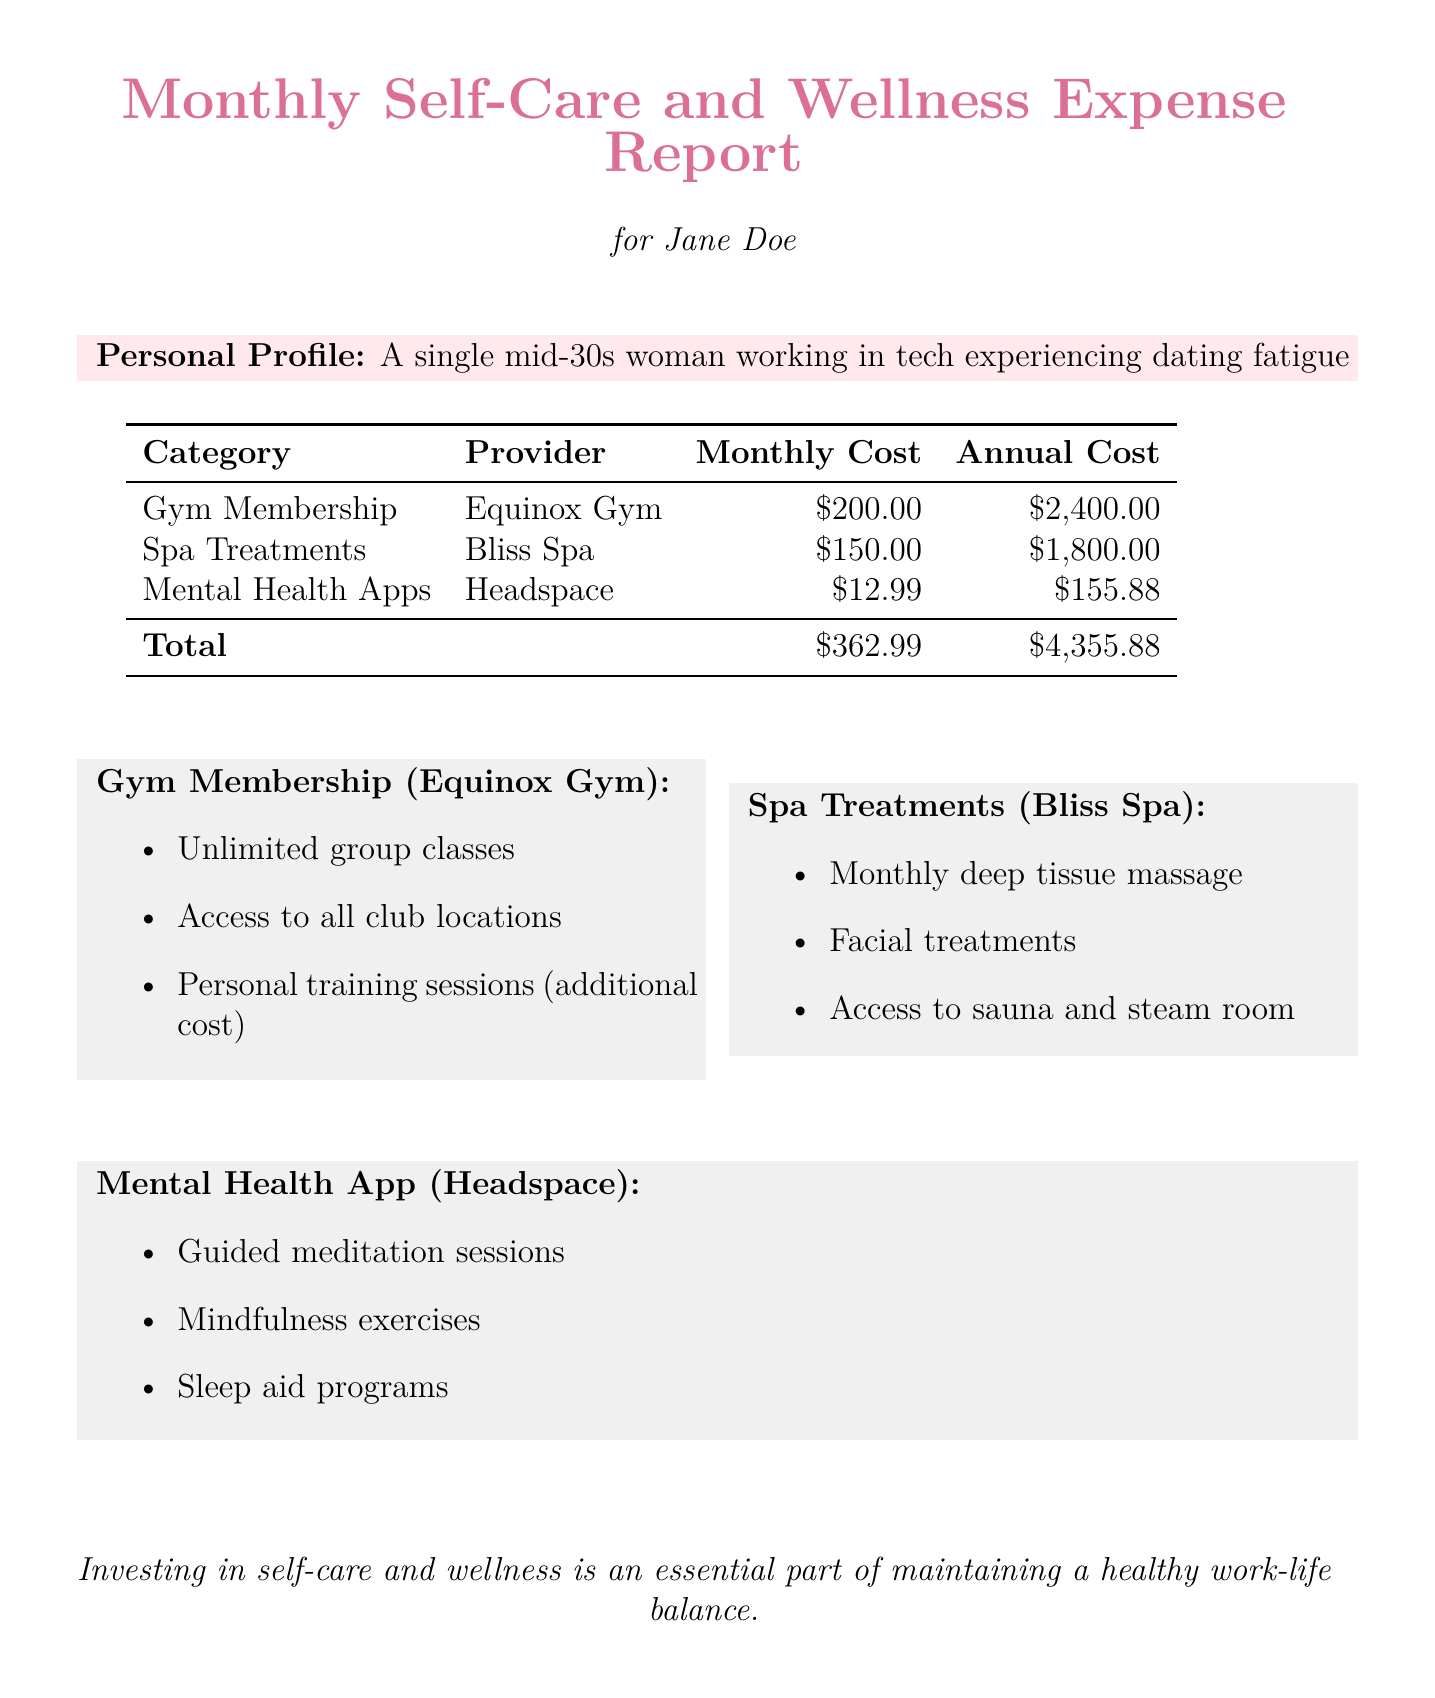What is the monthly cost of the gym membership? The monthly cost for the gym membership at Equinox Gym is specifically listed in the document.
Answer: $200.00 What is the annual cost of spa treatments? The annual cost for spa treatments at Bliss Spa is displayed in the expense report.
Answer: $1,800.00 Which mental health app is used for self-care? The document mentions Headspace as the mental health app for self-care and wellness.
Answer: Headspace What total amount is spent on self-care and wellness monthly? The total monthly cost is calculated by adding all individual expenses presented in the report.
Answer: $362.99 What is included with the gym membership? The document describes the benefits associated with the Equinox Gym membership, detailing what services are offered.
Answer: Unlimited group classes, Access to all club locations, Personal training sessions (additional cost) Which spa treatments are included monthly? The document lists specific spa treatments available as part of the Bliss Spa services, summarizing the offerings.
Answer: Monthly deep tissue massage, Facial treatments, Access to sauna and steam room What is the purpose of this expense report? The document includes a statement regarding the importance of investing in self-care and wellness for balance.
Answer: Maintaining a healthy work-life balance 